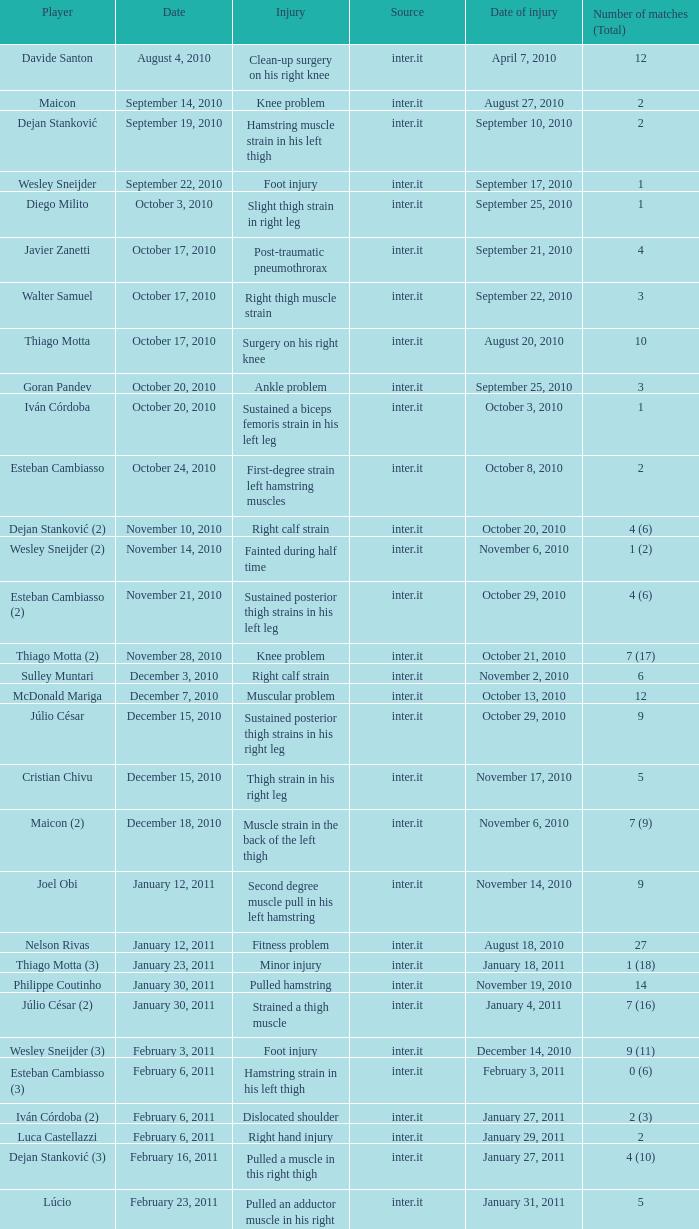How many times was the date october 3, 2010? 1.0. 